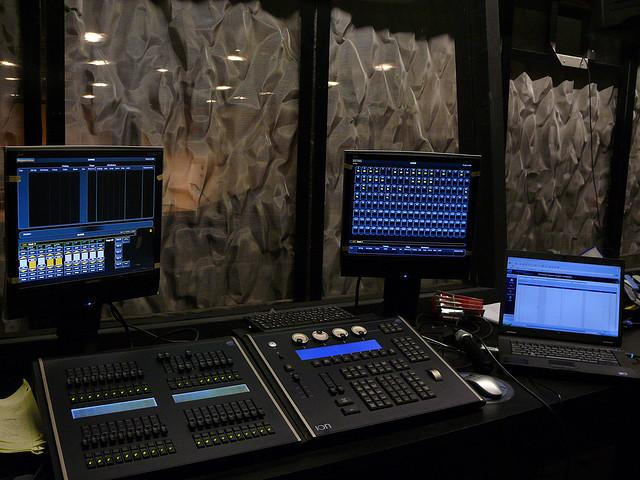The sliders on the equipment on the desk is used to adjust what? Please explain your reasoning. lighting. The sliders adjust the lighting. 